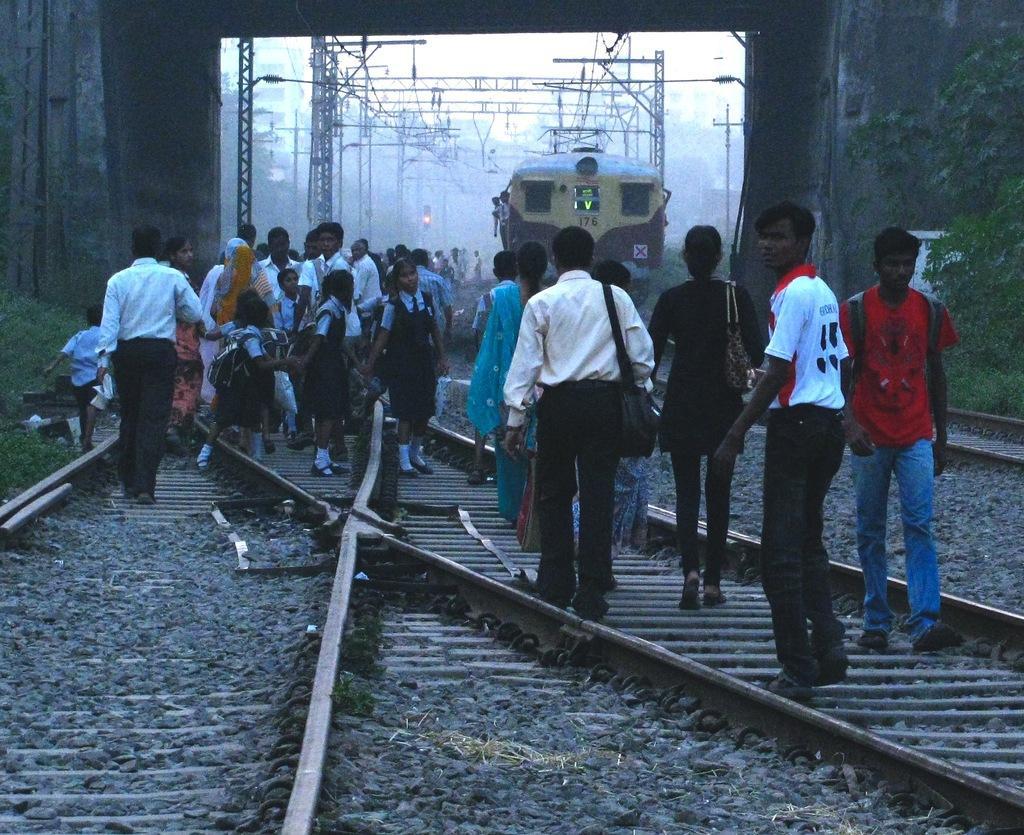Can you describe this image briefly? In this image there are a few people walking on the train tracks, beside the tracks there are pillars and trees, in front of them there is a train, besides the train there are electric poles and signal light. 